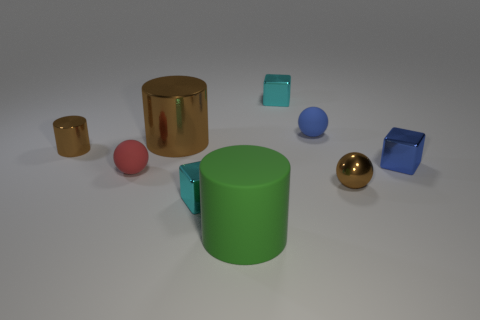Are there any big shiny cylinders in front of the small cyan metallic cube behind the small brown sphere?
Make the answer very short. Yes. What is the material of the brown cylinder that is the same size as the red ball?
Make the answer very short. Metal. Is there a yellow block that has the same size as the blue rubber thing?
Ensure brevity in your answer.  No. What is the sphere that is to the left of the large green matte cylinder made of?
Offer a very short reply. Rubber. Are the brown cylinder that is right of the red thing and the brown sphere made of the same material?
Your response must be concise. Yes. There is a rubber object that is the same size as the red rubber ball; what is its shape?
Your answer should be compact. Sphere. How many tiny things are the same color as the large metallic cylinder?
Ensure brevity in your answer.  2. Is the number of small brown cylinders that are behind the tiny cylinder less than the number of cylinders on the right side of the tiny red ball?
Offer a very short reply. Yes. Are there any small blue objects left of the tiny blue shiny cube?
Your answer should be very brief. Yes. There is a tiny ball to the left of the cyan metal cube to the left of the large green thing; is there a small matte object behind it?
Provide a short and direct response. Yes. 